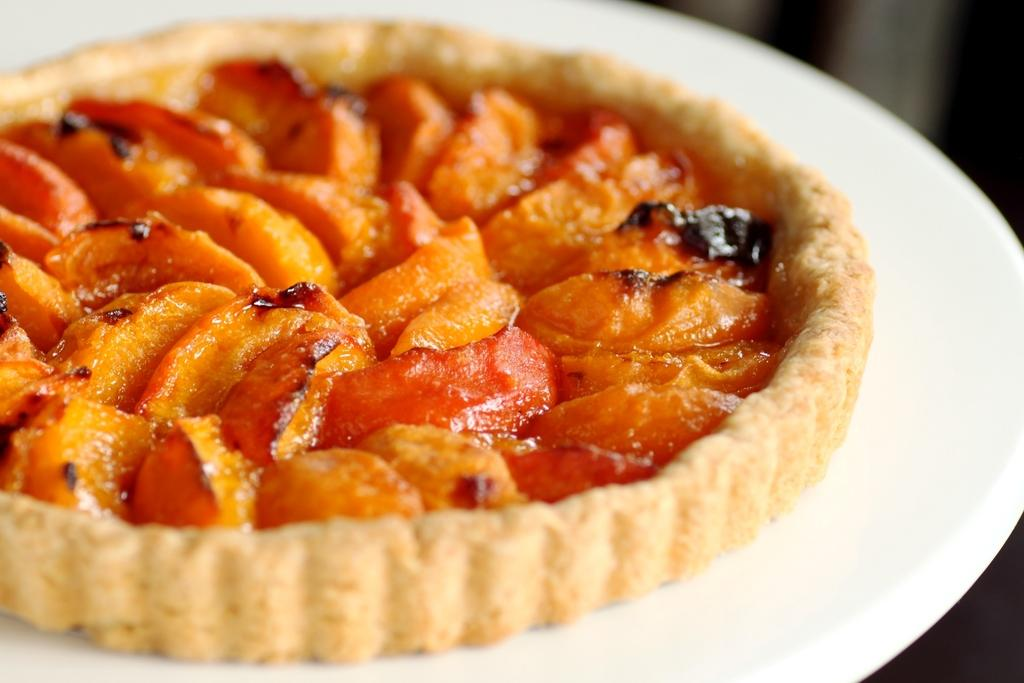What color is the plate that is visible in the image? The plate is white in color. What is on top of the plate in the image? There is a dish on the plate. What type of ornament is hanging from the toothbrush in the image? There is no toothbrush or ornament present in the image. 